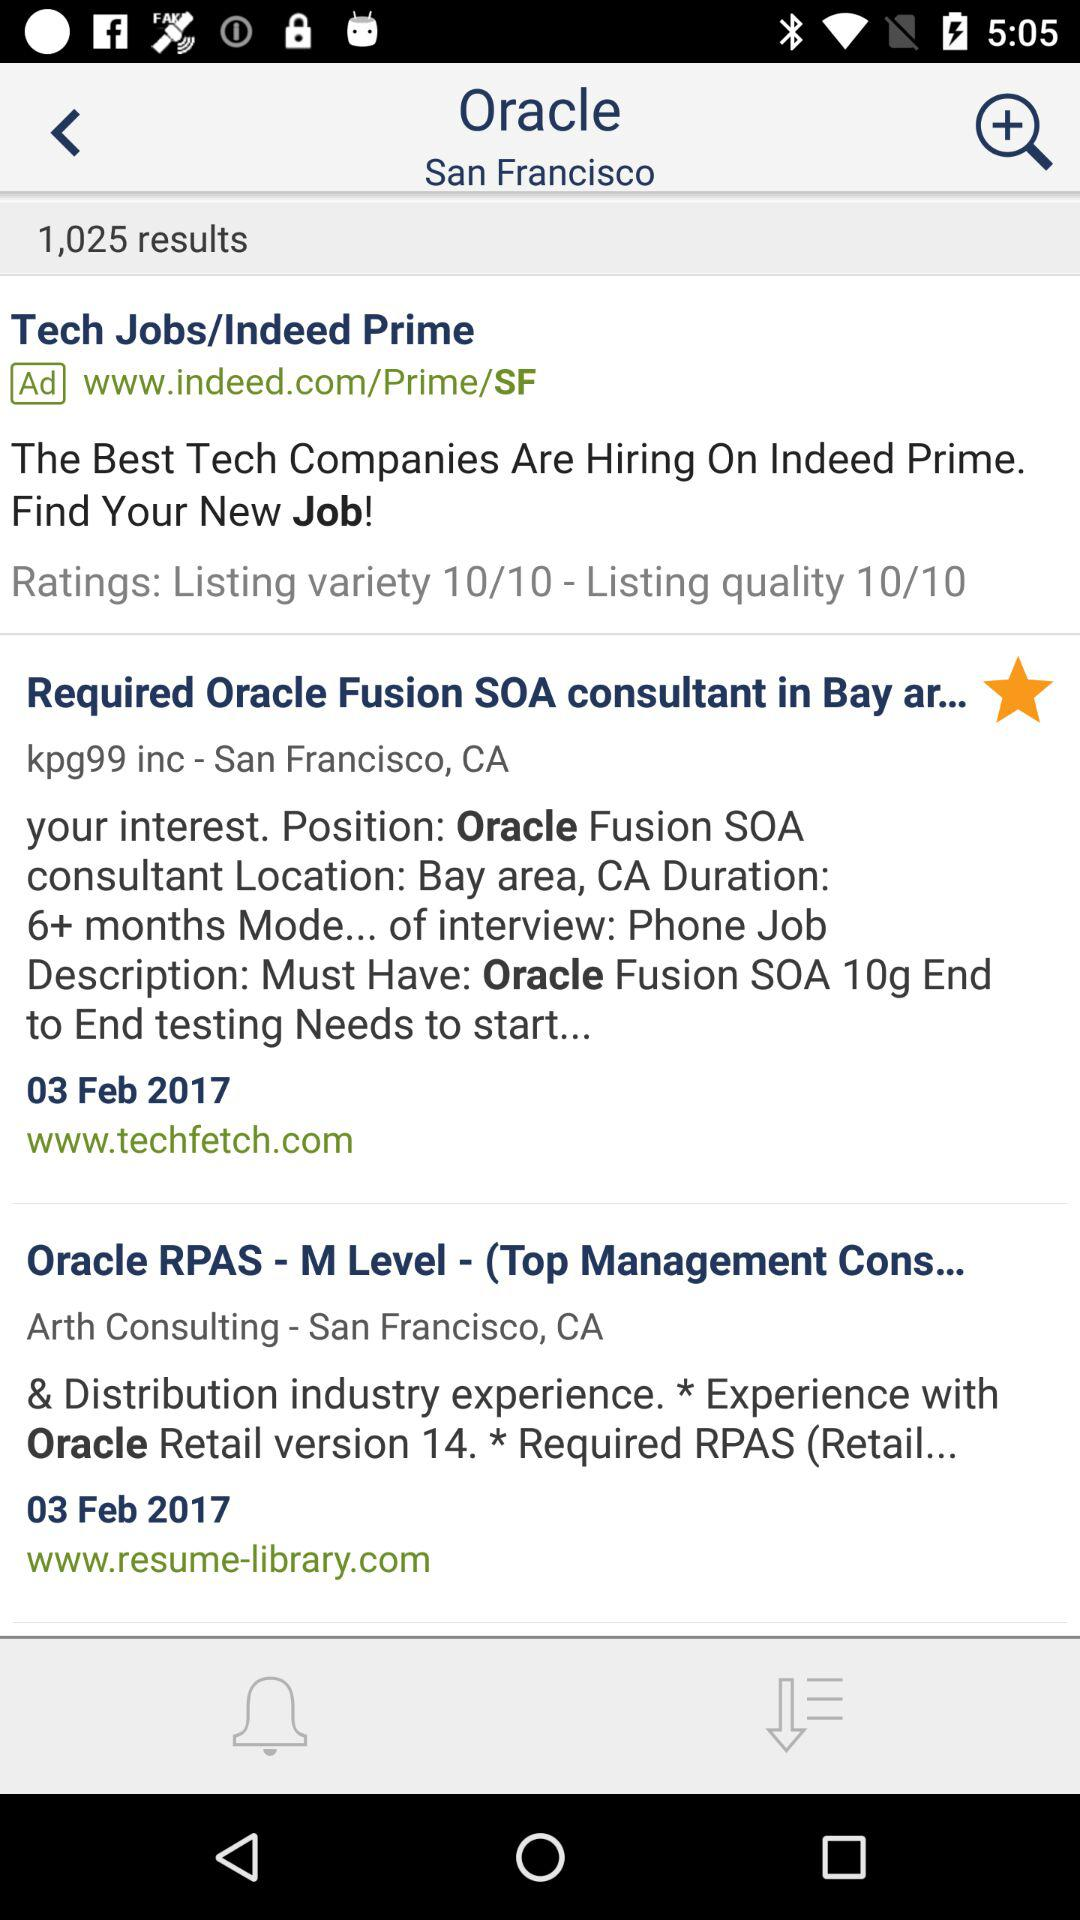What is the name of the application? The name of the application is "Oracle". 